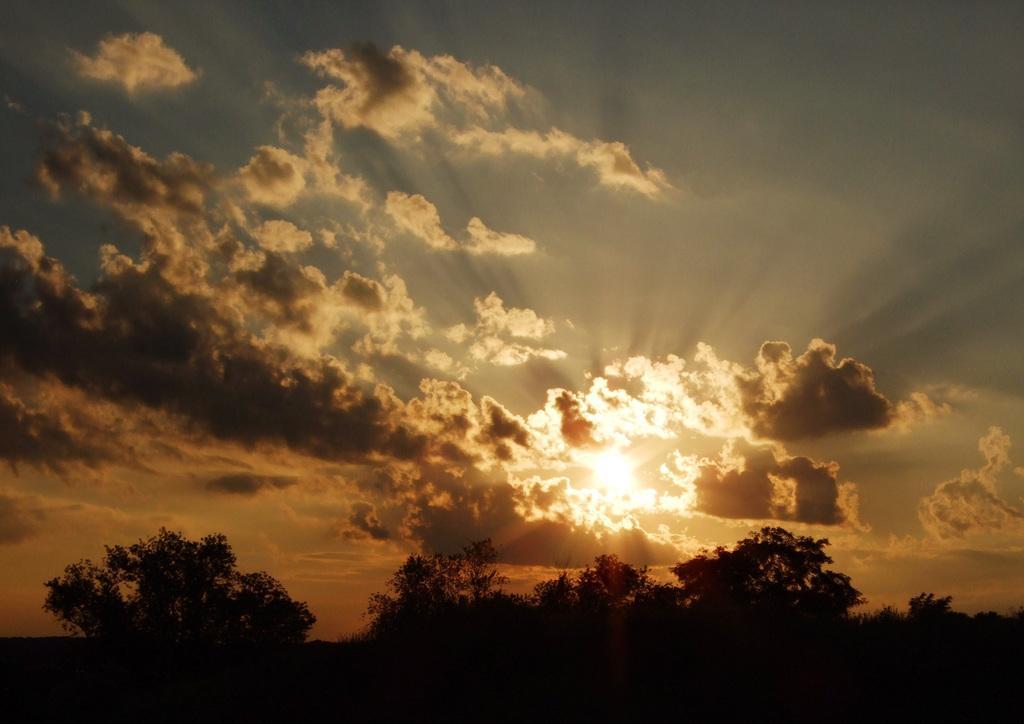Describe this image in one or two sentences. In the image we can see there are lot of trees and there is a sunset in the sky. 